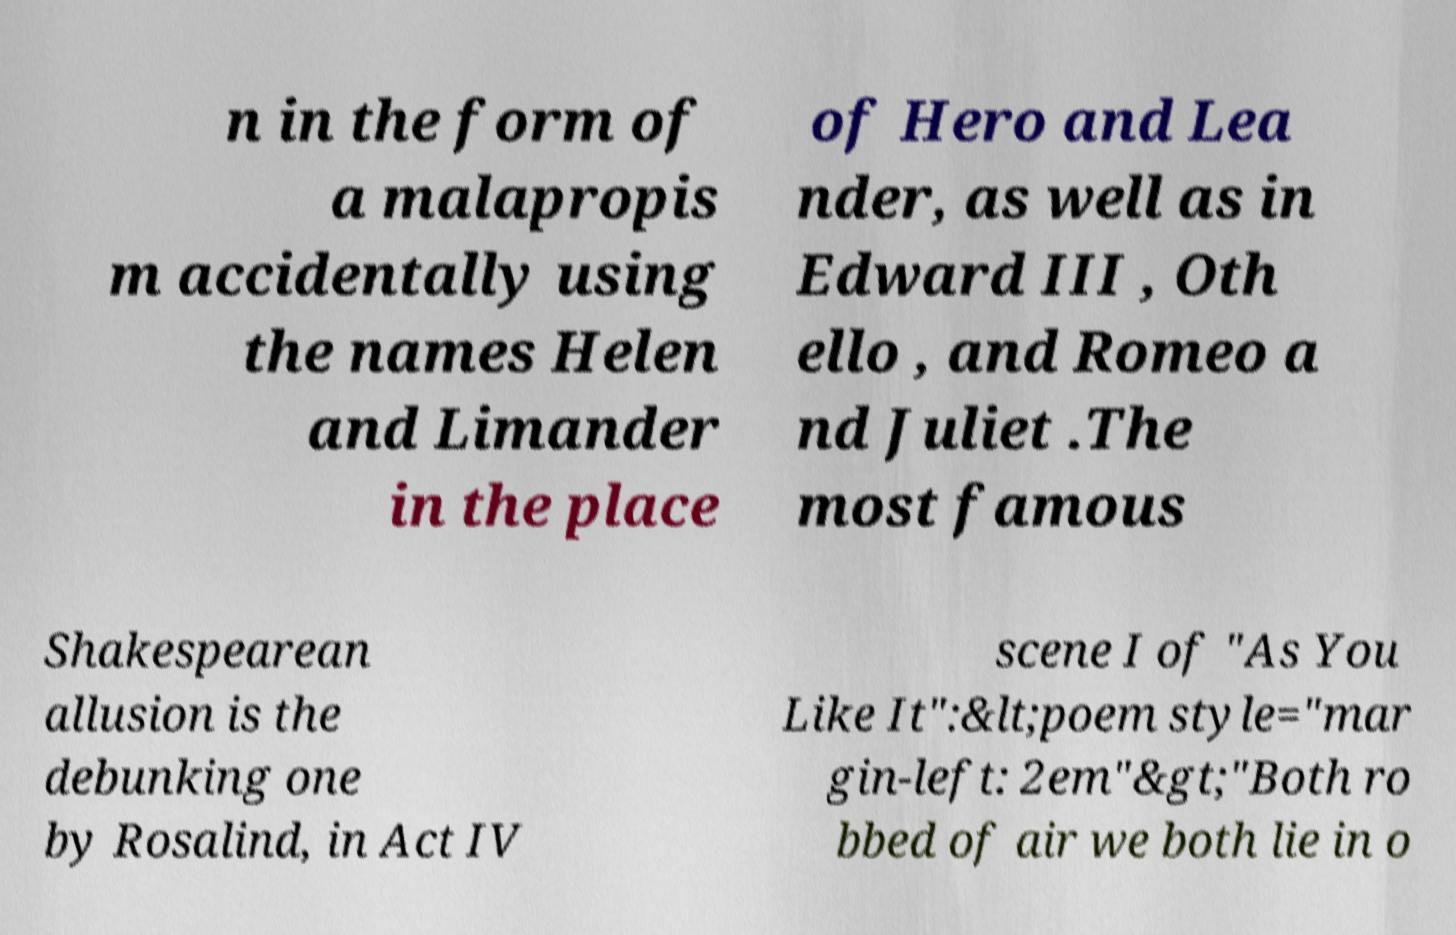Please identify and transcribe the text found in this image. n in the form of a malapropis m accidentally using the names Helen and Limander in the place of Hero and Lea nder, as well as in Edward III , Oth ello , and Romeo a nd Juliet .The most famous Shakespearean allusion is the debunking one by Rosalind, in Act IV scene I of "As You Like It":&lt;poem style="mar gin-left: 2em"&gt;"Both ro bbed of air we both lie in o 